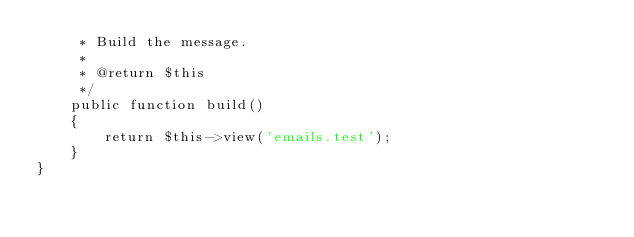Convert code to text. <code><loc_0><loc_0><loc_500><loc_500><_PHP_>     * Build the message.
     *
     * @return $this
     */
    public function build()
    {
        return $this->view('emails.test');
    }
}
</code> 